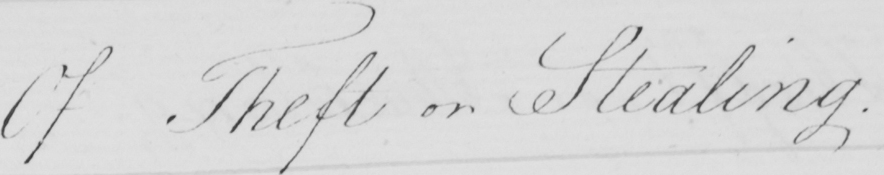Can you read and transcribe this handwriting? Of Theft or Stealing 